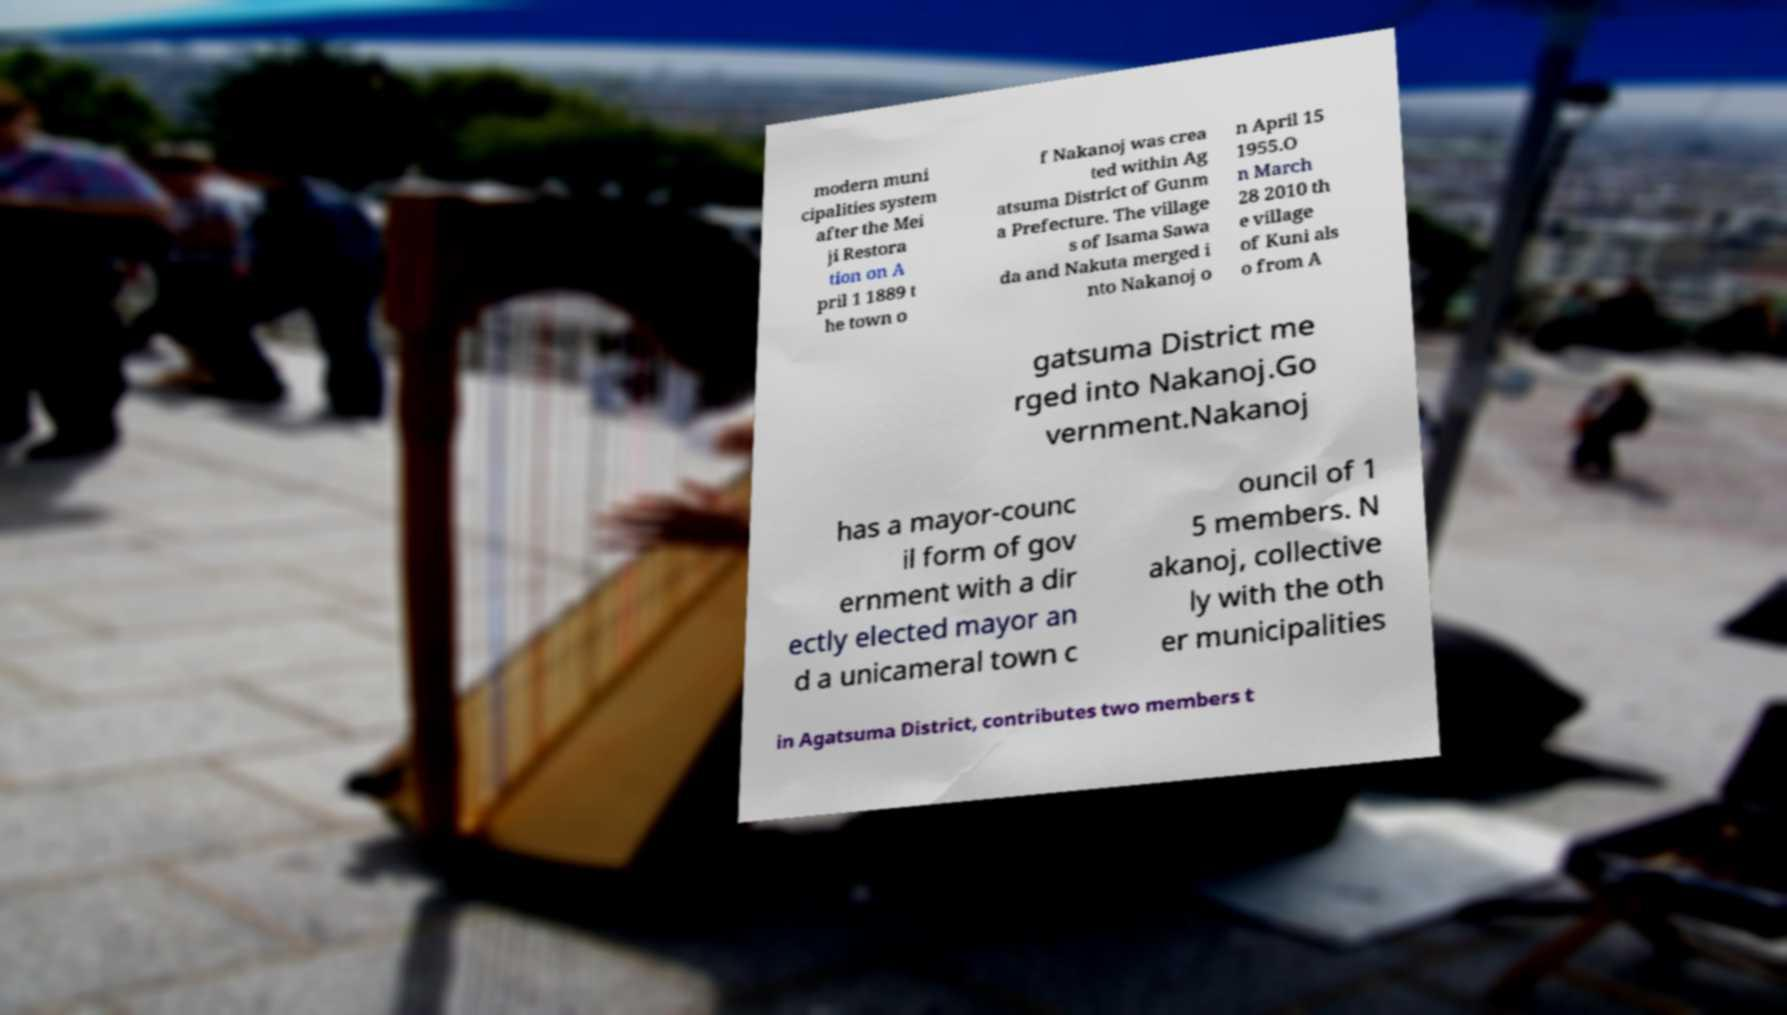Please read and relay the text visible in this image. What does it say? modern muni cipalities system after the Mei ji Restora tion on A pril 1 1889 t he town o f Nakanoj was crea ted within Ag atsuma District of Gunm a Prefecture. The village s of Isama Sawa da and Nakuta merged i nto Nakanoj o n April 15 1955.O n March 28 2010 th e village of Kuni als o from A gatsuma District me rged into Nakanoj.Go vernment.Nakanoj has a mayor-counc il form of gov ernment with a dir ectly elected mayor an d a unicameral town c ouncil of 1 5 members. N akanoj, collective ly with the oth er municipalities in Agatsuma District, contributes two members t 